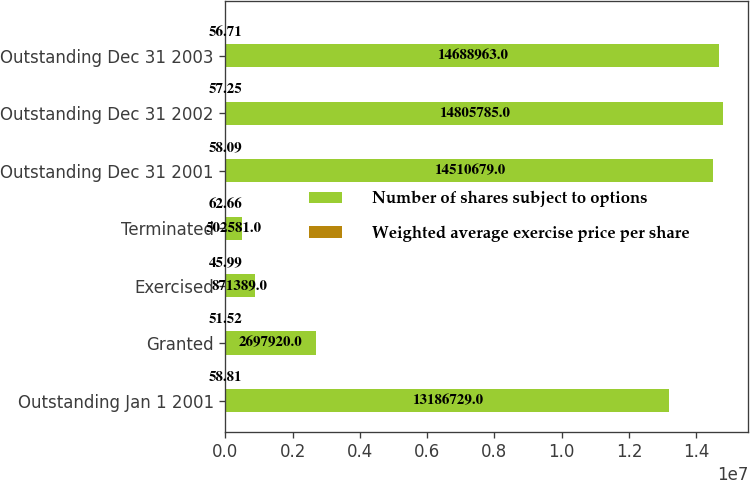Convert chart to OTSL. <chart><loc_0><loc_0><loc_500><loc_500><stacked_bar_chart><ecel><fcel>Outstanding Jan 1 2001<fcel>Granted<fcel>Exercised<fcel>Terminated<fcel>Outstanding Dec 31 2001<fcel>Outstanding Dec 31 2002<fcel>Outstanding Dec 31 2003<nl><fcel>Number of shares subject to options<fcel>1.31867e+07<fcel>2.69792e+06<fcel>871389<fcel>502581<fcel>1.45107e+07<fcel>1.48058e+07<fcel>1.4689e+07<nl><fcel>Weighted average exercise price per share<fcel>58.81<fcel>51.52<fcel>45.99<fcel>62.66<fcel>58.09<fcel>57.25<fcel>56.71<nl></chart> 